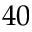<formula> <loc_0><loc_0><loc_500><loc_500>4 0</formula> 